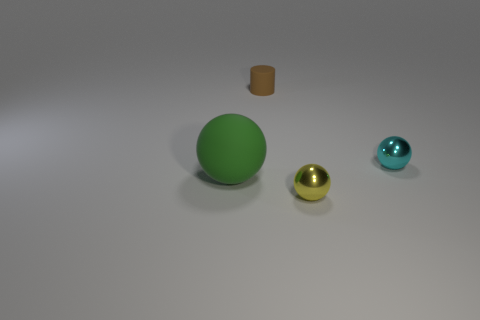Add 4 green matte objects. How many objects exist? 8 Subtract all cylinders. How many objects are left? 3 Add 3 small yellow objects. How many small yellow objects exist? 4 Subtract 1 cyan balls. How many objects are left? 3 Subtract all big cyan cylinders. Subtract all yellow shiny spheres. How many objects are left? 3 Add 1 green matte objects. How many green matte objects are left? 2 